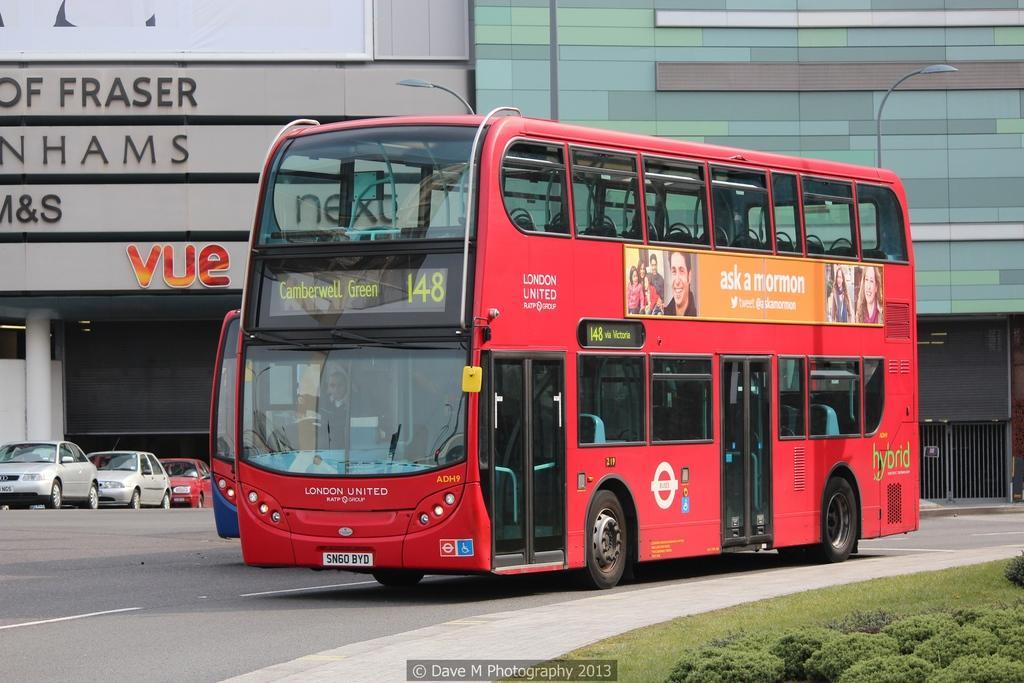In one or two sentences, can you explain what this image depicts? In this image we can see a red color bus on the road. In the background of the image there is a building with some text. There are cars. To the right side of the image there are grass, plants. 